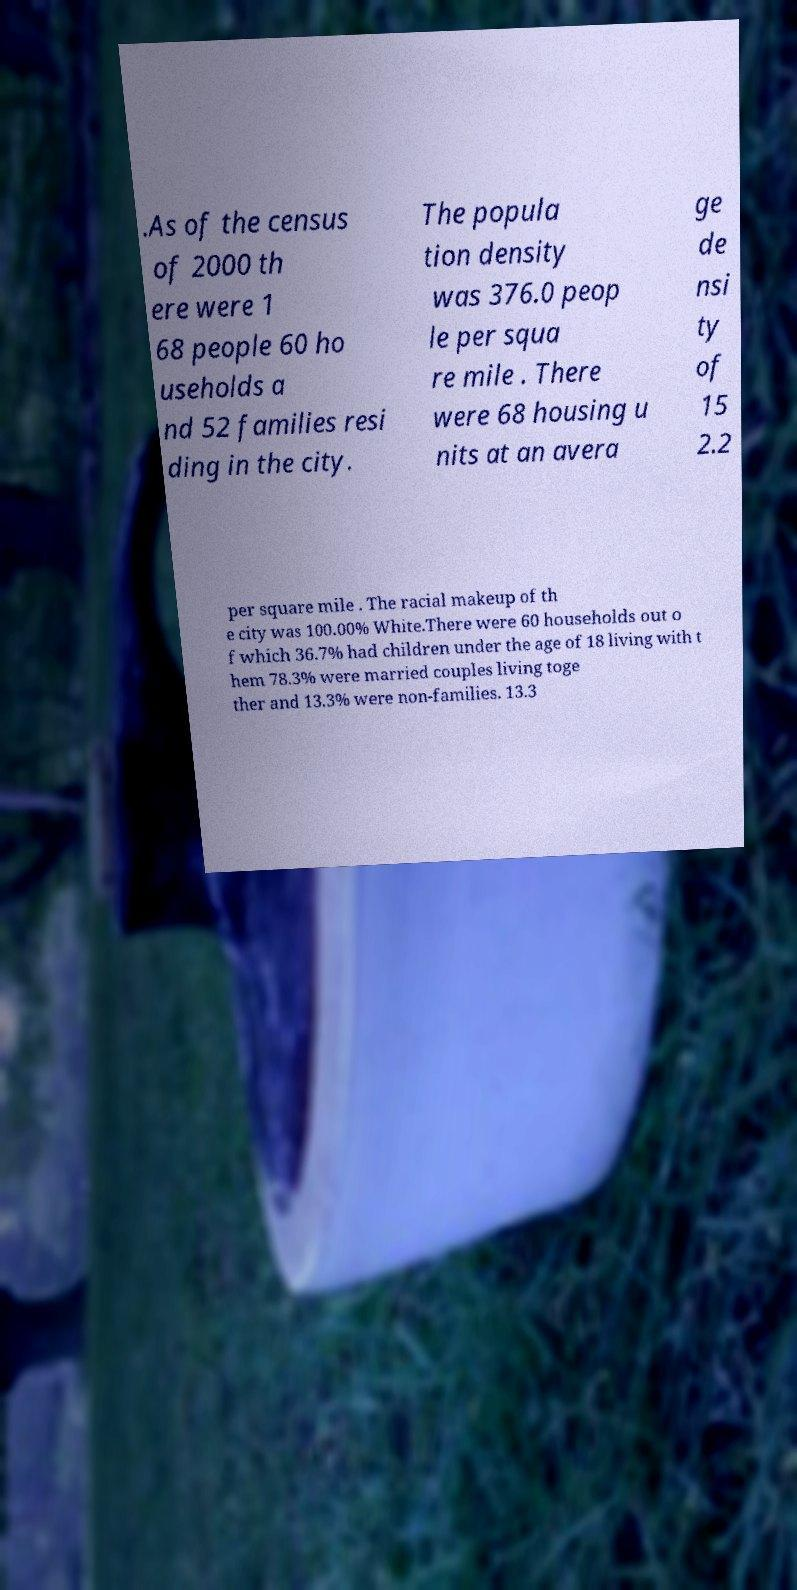Can you accurately transcribe the text from the provided image for me? .As of the census of 2000 th ere were 1 68 people 60 ho useholds a nd 52 families resi ding in the city. The popula tion density was 376.0 peop le per squa re mile . There were 68 housing u nits at an avera ge de nsi ty of 15 2.2 per square mile . The racial makeup of th e city was 100.00% White.There were 60 households out o f which 36.7% had children under the age of 18 living with t hem 78.3% were married couples living toge ther and 13.3% were non-families. 13.3 